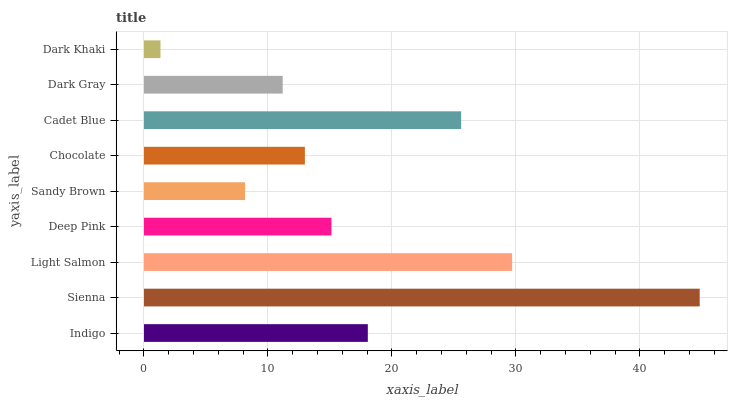Is Dark Khaki the minimum?
Answer yes or no. Yes. Is Sienna the maximum?
Answer yes or no. Yes. Is Light Salmon the minimum?
Answer yes or no. No. Is Light Salmon the maximum?
Answer yes or no. No. Is Sienna greater than Light Salmon?
Answer yes or no. Yes. Is Light Salmon less than Sienna?
Answer yes or no. Yes. Is Light Salmon greater than Sienna?
Answer yes or no. No. Is Sienna less than Light Salmon?
Answer yes or no. No. Is Deep Pink the high median?
Answer yes or no. Yes. Is Deep Pink the low median?
Answer yes or no. Yes. Is Dark Gray the high median?
Answer yes or no. No. Is Dark Khaki the low median?
Answer yes or no. No. 